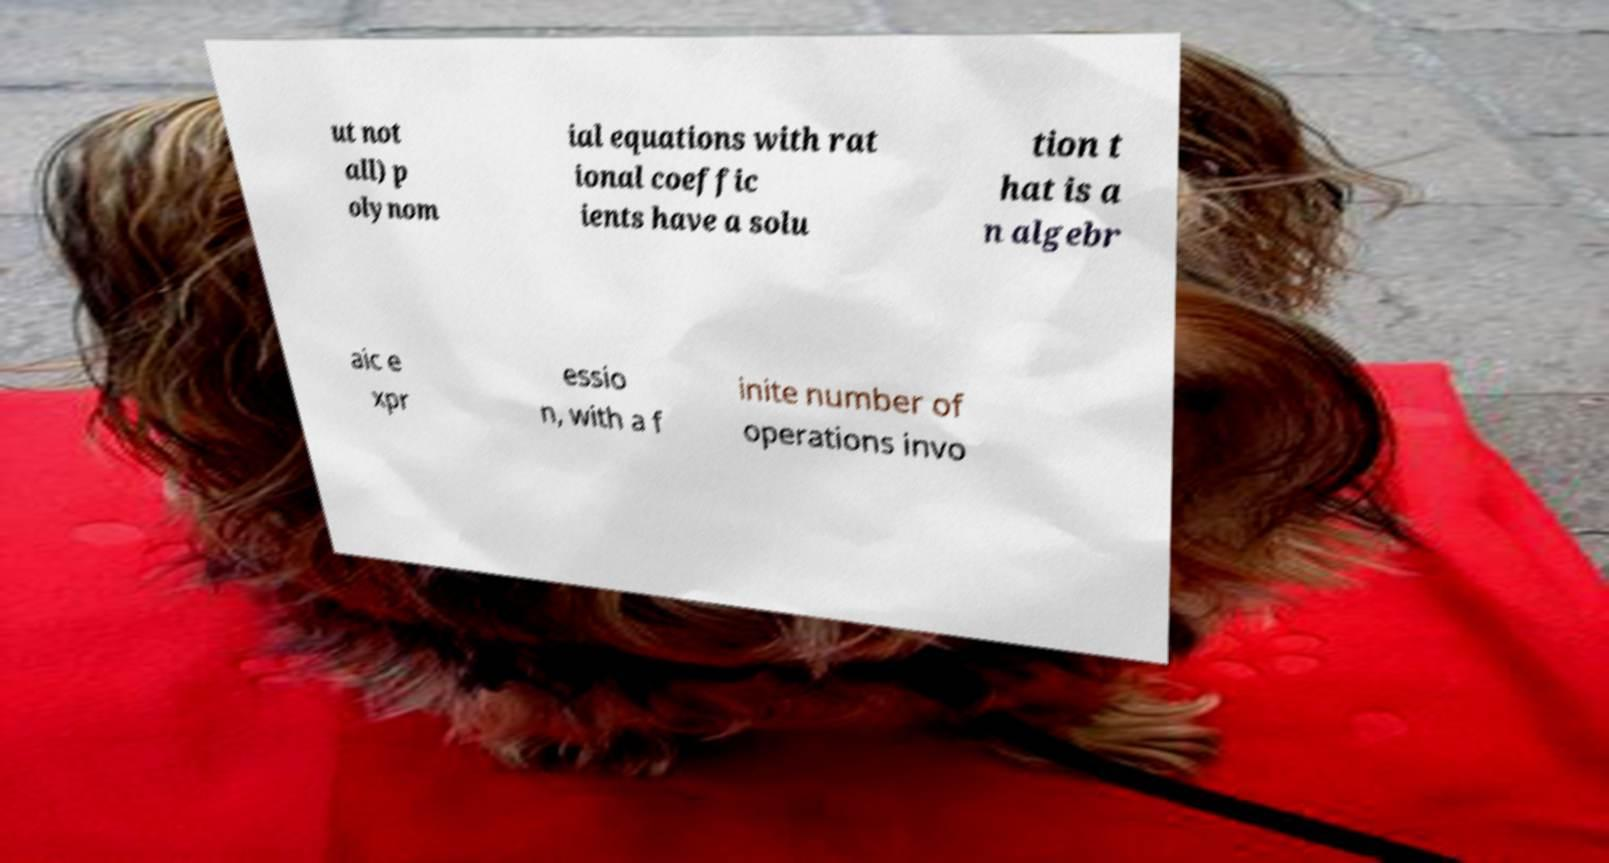I need the written content from this picture converted into text. Can you do that? ut not all) p olynom ial equations with rat ional coeffic ients have a solu tion t hat is a n algebr aic e xpr essio n, with a f inite number of operations invo 